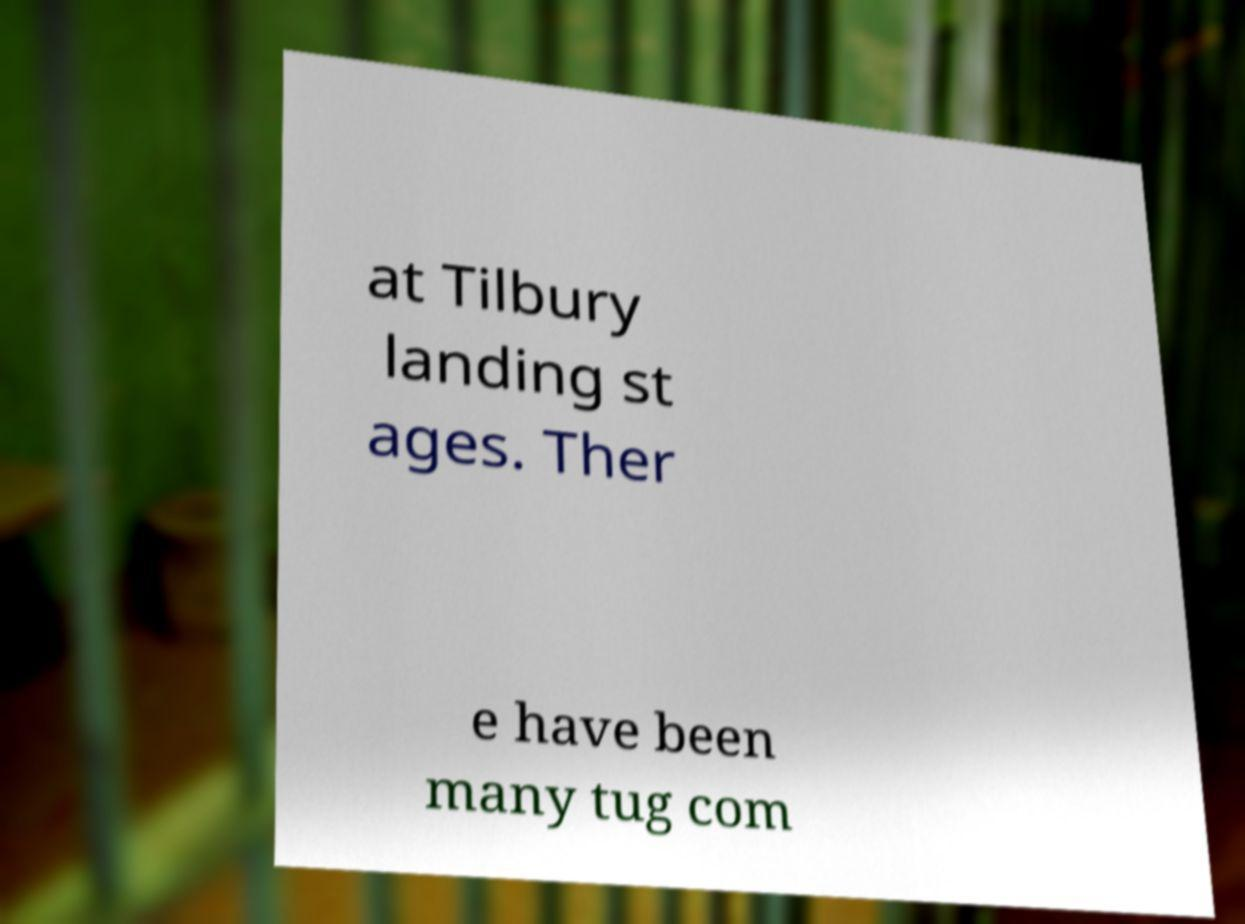Could you assist in decoding the text presented in this image and type it out clearly? at Tilbury landing st ages. Ther e have been many tug com 